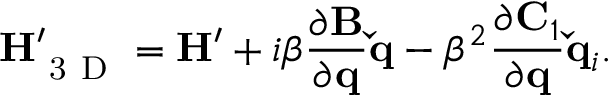Convert formula to latex. <formula><loc_0><loc_0><loc_500><loc_500>H _ { 3 D } ^ { \prime } = H ^ { \prime } + i \beta \frac { \partial B } { \partial q } \check { q } - \beta ^ { 2 } \frac { \partial C _ { 1 } } { \partial q } \check { q } _ { i } .</formula> 